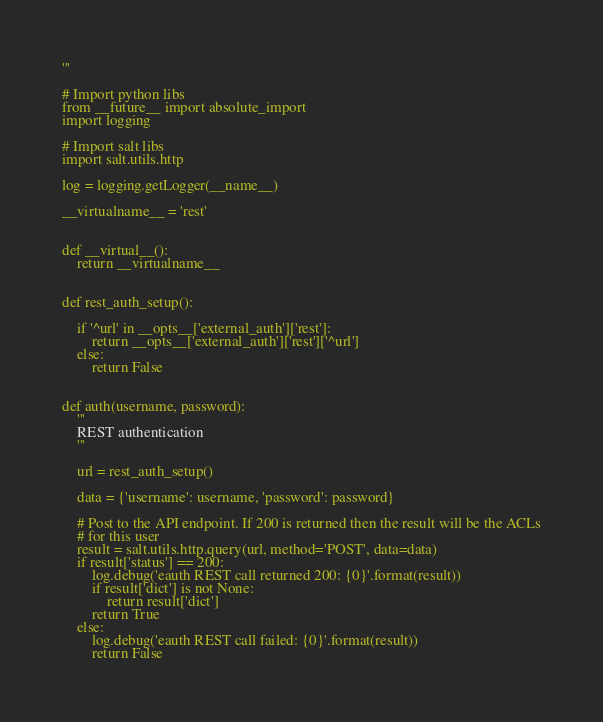<code> <loc_0><loc_0><loc_500><loc_500><_Python_>
'''

# Import python libs
from __future__ import absolute_import
import logging

# Import salt libs
import salt.utils.http

log = logging.getLogger(__name__)

__virtualname__ = 'rest'


def __virtual__():
    return __virtualname__


def rest_auth_setup():

    if '^url' in __opts__['external_auth']['rest']:
        return __opts__['external_auth']['rest']['^url']
    else:
        return False


def auth(username, password):
    '''
    REST authentication
    '''

    url = rest_auth_setup()

    data = {'username': username, 'password': password}

    # Post to the API endpoint. If 200 is returned then the result will be the ACLs
    # for this user
    result = salt.utils.http.query(url, method='POST', data=data)
    if result['status'] == 200:
        log.debug('eauth REST call returned 200: {0}'.format(result))
        if result['dict'] is not None:
            return result['dict']
        return True
    else:
        log.debug('eauth REST call failed: {0}'.format(result))
        return False
</code> 